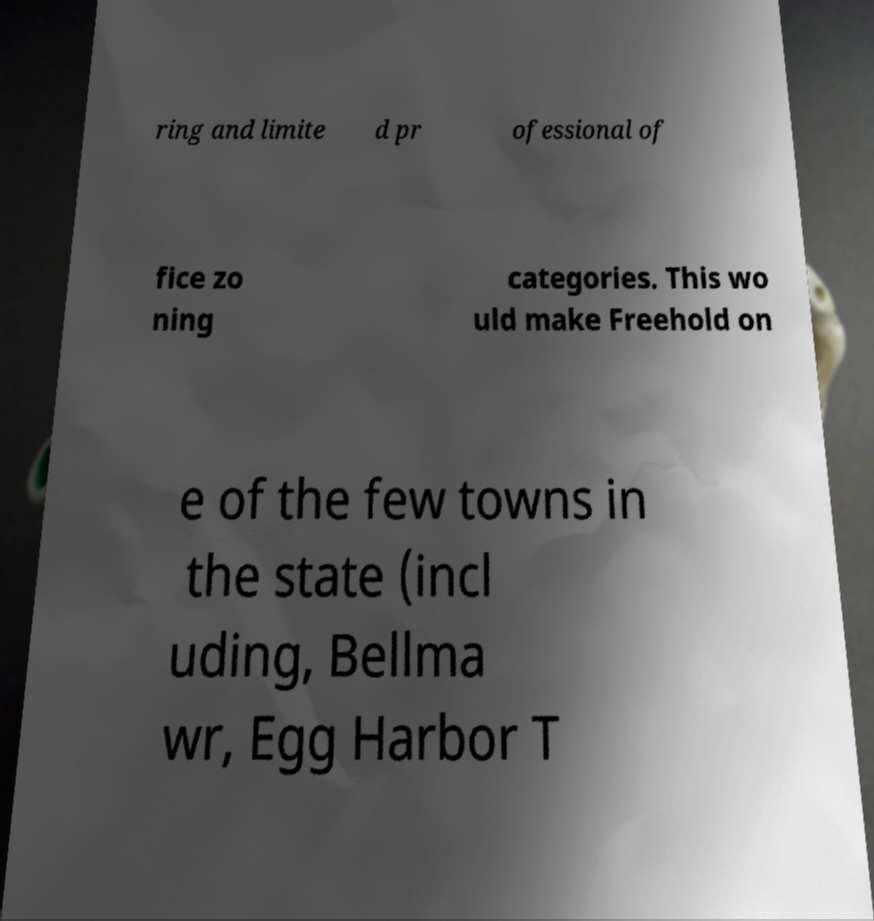Could you assist in decoding the text presented in this image and type it out clearly? ring and limite d pr ofessional of fice zo ning categories. This wo uld make Freehold on e of the few towns in the state (incl uding, Bellma wr, Egg Harbor T 